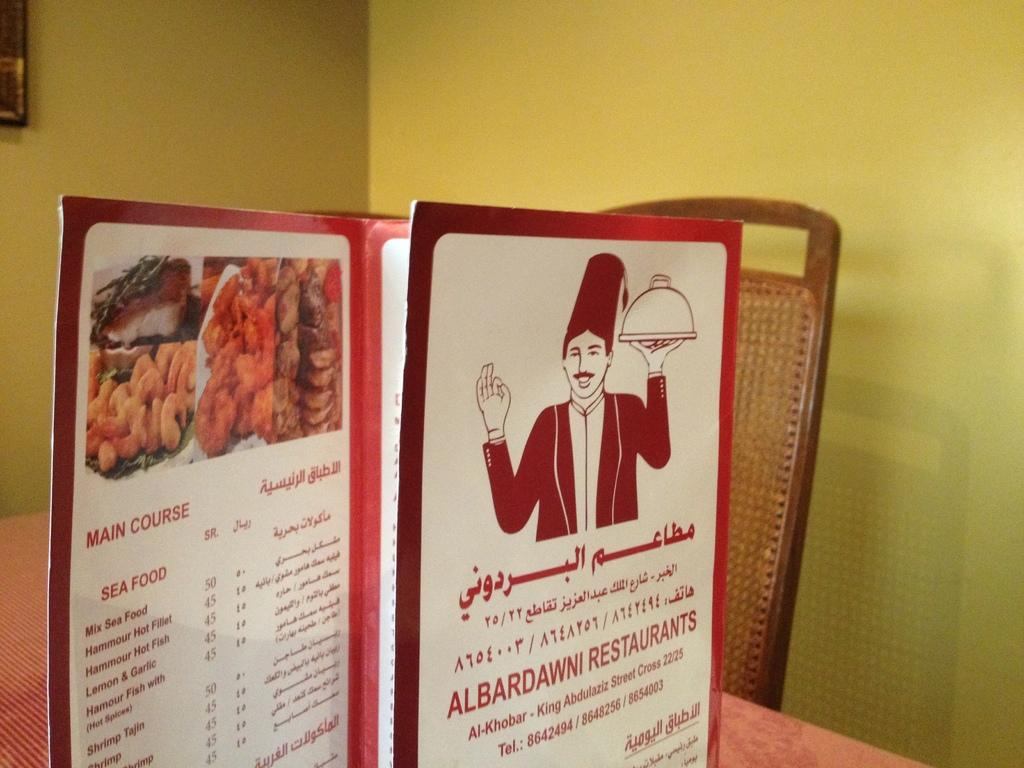What is placed on the table in the image? There is a menu card on the table. What type of furniture is visible in the image? There is a chair in the image. What can be seen hanging on the wall? There is a frame on the wall. How many tomatoes are on the chair in the image? There are no tomatoes present in the image. Is there a volcano visible in the frame on the wall? There is no volcano depicted in the frame on the wall; it is a different subject or object. 